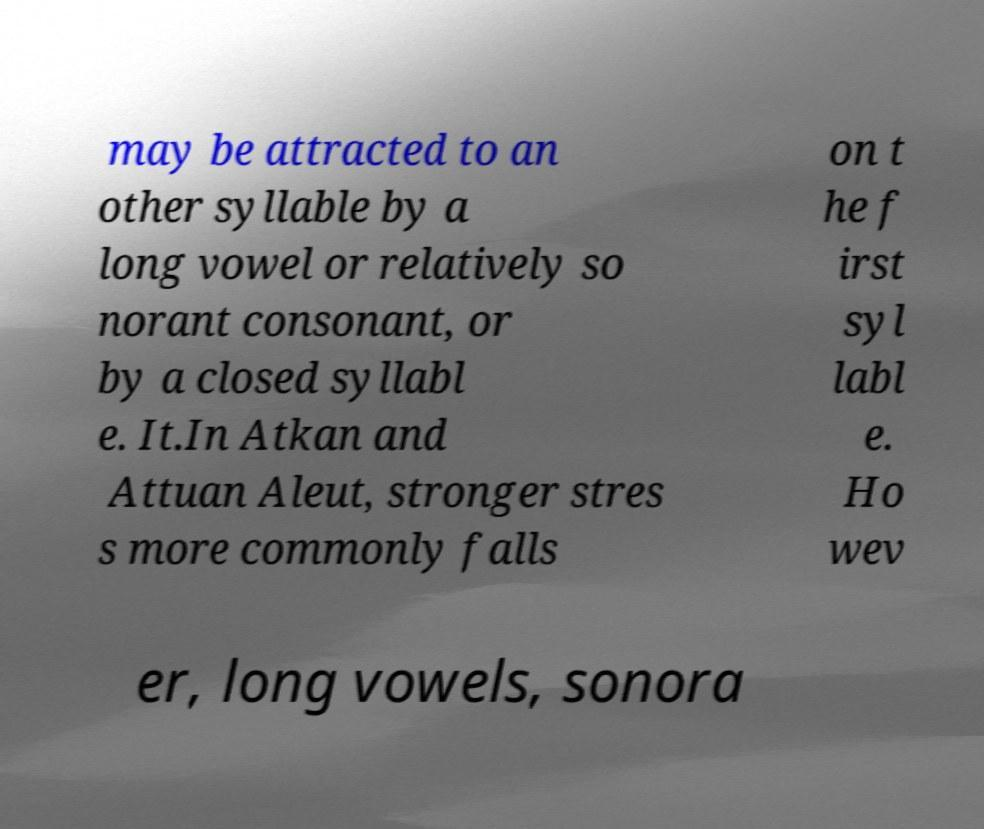Please read and relay the text visible in this image. What does it say? may be attracted to an other syllable by a long vowel or relatively so norant consonant, or by a closed syllabl e. It.In Atkan and Attuan Aleut, stronger stres s more commonly falls on t he f irst syl labl e. Ho wev er, long vowels, sonora 